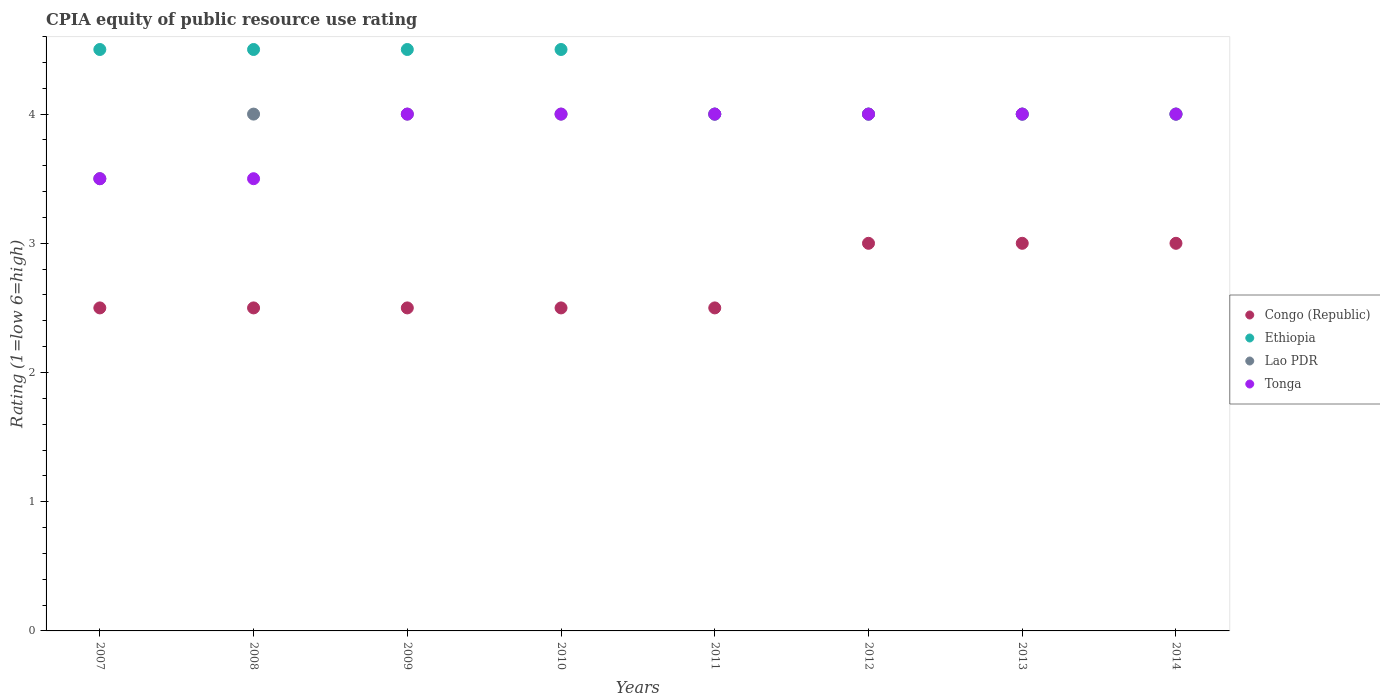Is the number of dotlines equal to the number of legend labels?
Keep it short and to the point. Yes. What is the CPIA rating in Ethiopia in 2007?
Provide a short and direct response. 4.5. Across all years, what is the maximum CPIA rating in Congo (Republic)?
Your answer should be compact. 3. In which year was the CPIA rating in Congo (Republic) maximum?
Your answer should be compact. 2012. What is the difference between the CPIA rating in Ethiopia in 2007 and that in 2013?
Your answer should be very brief. 0.5. What is the difference between the CPIA rating in Congo (Republic) in 2012 and the CPIA rating in Tonga in 2008?
Your response must be concise. -0.5. What is the average CPIA rating in Lao PDR per year?
Your answer should be very brief. 3.94. In the year 2012, what is the difference between the CPIA rating in Tonga and CPIA rating in Congo (Republic)?
Offer a very short reply. 1. What is the ratio of the CPIA rating in Congo (Republic) in 2010 to that in 2013?
Make the answer very short. 0.83. What is the difference between the highest and the second highest CPIA rating in Tonga?
Your response must be concise. 0. Is the sum of the CPIA rating in Lao PDR in 2008 and 2011 greater than the maximum CPIA rating in Congo (Republic) across all years?
Offer a terse response. Yes. Is it the case that in every year, the sum of the CPIA rating in Congo (Republic) and CPIA rating in Lao PDR  is greater than the CPIA rating in Tonga?
Provide a short and direct response. Yes. Does the CPIA rating in Congo (Republic) monotonically increase over the years?
Provide a short and direct response. No. How many years are there in the graph?
Make the answer very short. 8. Does the graph contain any zero values?
Offer a very short reply. No. How many legend labels are there?
Give a very brief answer. 4. What is the title of the graph?
Make the answer very short. CPIA equity of public resource use rating. What is the label or title of the Y-axis?
Offer a terse response. Rating (1=low 6=high). What is the Rating (1=low 6=high) of Ethiopia in 2007?
Offer a very short reply. 4.5. What is the Rating (1=low 6=high) in Lao PDR in 2007?
Your answer should be compact. 3.5. What is the Rating (1=low 6=high) of Congo (Republic) in 2008?
Provide a short and direct response. 2.5. What is the Rating (1=low 6=high) of Lao PDR in 2008?
Make the answer very short. 4. What is the Rating (1=low 6=high) in Tonga in 2008?
Offer a terse response. 3.5. What is the Rating (1=low 6=high) of Congo (Republic) in 2010?
Your answer should be compact. 2.5. What is the Rating (1=low 6=high) of Lao PDR in 2010?
Offer a very short reply. 4. What is the Rating (1=low 6=high) in Congo (Republic) in 2011?
Your answer should be very brief. 2.5. What is the Rating (1=low 6=high) in Ethiopia in 2011?
Offer a terse response. 4. What is the Rating (1=low 6=high) in Tonga in 2011?
Offer a very short reply. 4. What is the Rating (1=low 6=high) in Congo (Republic) in 2012?
Offer a terse response. 3. What is the Rating (1=low 6=high) of Tonga in 2013?
Offer a very short reply. 4. What is the Rating (1=low 6=high) of Ethiopia in 2014?
Give a very brief answer. 4. What is the Rating (1=low 6=high) of Lao PDR in 2014?
Ensure brevity in your answer.  4. Across all years, what is the maximum Rating (1=low 6=high) of Ethiopia?
Your answer should be compact. 4.5. Across all years, what is the maximum Rating (1=low 6=high) of Lao PDR?
Offer a terse response. 4. Across all years, what is the maximum Rating (1=low 6=high) of Tonga?
Ensure brevity in your answer.  4. Across all years, what is the minimum Rating (1=low 6=high) in Lao PDR?
Give a very brief answer. 3.5. Across all years, what is the minimum Rating (1=low 6=high) of Tonga?
Ensure brevity in your answer.  3.5. What is the total Rating (1=low 6=high) of Ethiopia in the graph?
Keep it short and to the point. 34. What is the total Rating (1=low 6=high) in Lao PDR in the graph?
Offer a very short reply. 31.5. What is the total Rating (1=low 6=high) in Tonga in the graph?
Keep it short and to the point. 31. What is the difference between the Rating (1=low 6=high) in Congo (Republic) in 2007 and that in 2008?
Your answer should be compact. 0. What is the difference between the Rating (1=low 6=high) in Tonga in 2007 and that in 2008?
Provide a succinct answer. 0. What is the difference between the Rating (1=low 6=high) in Congo (Republic) in 2007 and that in 2009?
Offer a very short reply. 0. What is the difference between the Rating (1=low 6=high) of Ethiopia in 2007 and that in 2009?
Make the answer very short. 0. What is the difference between the Rating (1=low 6=high) in Lao PDR in 2007 and that in 2009?
Keep it short and to the point. -0.5. What is the difference between the Rating (1=low 6=high) in Tonga in 2007 and that in 2009?
Make the answer very short. -0.5. What is the difference between the Rating (1=low 6=high) of Congo (Republic) in 2007 and that in 2010?
Ensure brevity in your answer.  0. What is the difference between the Rating (1=low 6=high) of Tonga in 2007 and that in 2010?
Ensure brevity in your answer.  -0.5. What is the difference between the Rating (1=low 6=high) in Tonga in 2007 and that in 2011?
Ensure brevity in your answer.  -0.5. What is the difference between the Rating (1=low 6=high) in Congo (Republic) in 2007 and that in 2013?
Make the answer very short. -0.5. What is the difference between the Rating (1=low 6=high) of Lao PDR in 2007 and that in 2013?
Your answer should be compact. -0.5. What is the difference between the Rating (1=low 6=high) in Tonga in 2007 and that in 2013?
Provide a short and direct response. -0.5. What is the difference between the Rating (1=low 6=high) of Congo (Republic) in 2007 and that in 2014?
Ensure brevity in your answer.  -0.5. What is the difference between the Rating (1=low 6=high) of Lao PDR in 2007 and that in 2014?
Your answer should be compact. -0.5. What is the difference between the Rating (1=low 6=high) of Ethiopia in 2008 and that in 2009?
Ensure brevity in your answer.  0. What is the difference between the Rating (1=low 6=high) of Lao PDR in 2008 and that in 2009?
Make the answer very short. 0. What is the difference between the Rating (1=low 6=high) of Congo (Republic) in 2008 and that in 2010?
Keep it short and to the point. 0. What is the difference between the Rating (1=low 6=high) in Ethiopia in 2008 and that in 2010?
Keep it short and to the point. 0. What is the difference between the Rating (1=low 6=high) of Lao PDR in 2008 and that in 2010?
Provide a succinct answer. 0. What is the difference between the Rating (1=low 6=high) of Congo (Republic) in 2008 and that in 2011?
Your answer should be compact. 0. What is the difference between the Rating (1=low 6=high) of Ethiopia in 2008 and that in 2011?
Offer a terse response. 0.5. What is the difference between the Rating (1=low 6=high) of Lao PDR in 2008 and that in 2011?
Give a very brief answer. 0. What is the difference between the Rating (1=low 6=high) of Tonga in 2008 and that in 2011?
Give a very brief answer. -0.5. What is the difference between the Rating (1=low 6=high) of Congo (Republic) in 2008 and that in 2012?
Offer a terse response. -0.5. What is the difference between the Rating (1=low 6=high) in Ethiopia in 2008 and that in 2012?
Your response must be concise. 0.5. What is the difference between the Rating (1=low 6=high) of Ethiopia in 2008 and that in 2013?
Offer a very short reply. 0.5. What is the difference between the Rating (1=low 6=high) of Congo (Republic) in 2008 and that in 2014?
Your answer should be compact. -0.5. What is the difference between the Rating (1=low 6=high) in Tonga in 2008 and that in 2014?
Ensure brevity in your answer.  -0.5. What is the difference between the Rating (1=low 6=high) in Congo (Republic) in 2009 and that in 2010?
Make the answer very short. 0. What is the difference between the Rating (1=low 6=high) in Ethiopia in 2009 and that in 2010?
Provide a short and direct response. 0. What is the difference between the Rating (1=low 6=high) in Lao PDR in 2009 and that in 2010?
Offer a terse response. 0. What is the difference between the Rating (1=low 6=high) in Tonga in 2009 and that in 2010?
Make the answer very short. 0. What is the difference between the Rating (1=low 6=high) of Tonga in 2009 and that in 2012?
Ensure brevity in your answer.  0. What is the difference between the Rating (1=low 6=high) in Congo (Republic) in 2009 and that in 2013?
Provide a succinct answer. -0.5. What is the difference between the Rating (1=low 6=high) of Tonga in 2009 and that in 2013?
Provide a succinct answer. 0. What is the difference between the Rating (1=low 6=high) of Ethiopia in 2009 and that in 2014?
Your answer should be very brief. 0.5. What is the difference between the Rating (1=low 6=high) in Tonga in 2009 and that in 2014?
Keep it short and to the point. 0. What is the difference between the Rating (1=low 6=high) of Lao PDR in 2010 and that in 2011?
Provide a short and direct response. 0. What is the difference between the Rating (1=low 6=high) of Tonga in 2010 and that in 2011?
Ensure brevity in your answer.  0. What is the difference between the Rating (1=low 6=high) of Congo (Republic) in 2010 and that in 2012?
Offer a very short reply. -0.5. What is the difference between the Rating (1=low 6=high) in Ethiopia in 2010 and that in 2012?
Your response must be concise. 0.5. What is the difference between the Rating (1=low 6=high) in Ethiopia in 2010 and that in 2013?
Provide a succinct answer. 0.5. What is the difference between the Rating (1=low 6=high) of Congo (Republic) in 2010 and that in 2014?
Give a very brief answer. -0.5. What is the difference between the Rating (1=low 6=high) in Ethiopia in 2010 and that in 2014?
Make the answer very short. 0.5. What is the difference between the Rating (1=low 6=high) in Lao PDR in 2010 and that in 2014?
Your response must be concise. 0. What is the difference between the Rating (1=low 6=high) of Tonga in 2010 and that in 2014?
Provide a short and direct response. 0. What is the difference between the Rating (1=low 6=high) in Congo (Republic) in 2011 and that in 2012?
Offer a very short reply. -0.5. What is the difference between the Rating (1=low 6=high) of Ethiopia in 2011 and that in 2012?
Provide a succinct answer. 0. What is the difference between the Rating (1=low 6=high) of Tonga in 2011 and that in 2012?
Provide a short and direct response. 0. What is the difference between the Rating (1=low 6=high) in Congo (Republic) in 2011 and that in 2013?
Give a very brief answer. -0.5. What is the difference between the Rating (1=low 6=high) of Ethiopia in 2011 and that in 2013?
Make the answer very short. 0. What is the difference between the Rating (1=low 6=high) of Congo (Republic) in 2011 and that in 2014?
Your answer should be compact. -0.5. What is the difference between the Rating (1=low 6=high) of Lao PDR in 2011 and that in 2014?
Ensure brevity in your answer.  0. What is the difference between the Rating (1=low 6=high) of Congo (Republic) in 2012 and that in 2013?
Make the answer very short. 0. What is the difference between the Rating (1=low 6=high) of Ethiopia in 2012 and that in 2013?
Give a very brief answer. 0. What is the difference between the Rating (1=low 6=high) in Lao PDR in 2012 and that in 2013?
Ensure brevity in your answer.  0. What is the difference between the Rating (1=low 6=high) of Tonga in 2012 and that in 2013?
Your answer should be very brief. 0. What is the difference between the Rating (1=low 6=high) in Ethiopia in 2012 and that in 2014?
Give a very brief answer. 0. What is the difference between the Rating (1=low 6=high) of Lao PDR in 2012 and that in 2014?
Your response must be concise. 0. What is the difference between the Rating (1=low 6=high) in Tonga in 2012 and that in 2014?
Make the answer very short. 0. What is the difference between the Rating (1=low 6=high) of Congo (Republic) in 2013 and that in 2014?
Your answer should be very brief. 0. What is the difference between the Rating (1=low 6=high) in Ethiopia in 2013 and that in 2014?
Ensure brevity in your answer.  0. What is the difference between the Rating (1=low 6=high) in Congo (Republic) in 2007 and the Rating (1=low 6=high) in Ethiopia in 2008?
Your response must be concise. -2. What is the difference between the Rating (1=low 6=high) of Congo (Republic) in 2007 and the Rating (1=low 6=high) of Tonga in 2008?
Your answer should be very brief. -1. What is the difference between the Rating (1=low 6=high) in Congo (Republic) in 2007 and the Rating (1=low 6=high) in Ethiopia in 2009?
Provide a short and direct response. -2. What is the difference between the Rating (1=low 6=high) of Congo (Republic) in 2007 and the Rating (1=low 6=high) of Lao PDR in 2009?
Your response must be concise. -1.5. What is the difference between the Rating (1=low 6=high) of Ethiopia in 2007 and the Rating (1=low 6=high) of Lao PDR in 2009?
Offer a terse response. 0.5. What is the difference between the Rating (1=low 6=high) of Ethiopia in 2007 and the Rating (1=low 6=high) of Tonga in 2009?
Ensure brevity in your answer.  0.5. What is the difference between the Rating (1=low 6=high) in Lao PDR in 2007 and the Rating (1=low 6=high) in Tonga in 2010?
Provide a succinct answer. -0.5. What is the difference between the Rating (1=low 6=high) of Congo (Republic) in 2007 and the Rating (1=low 6=high) of Lao PDR in 2011?
Offer a terse response. -1.5. What is the difference between the Rating (1=low 6=high) in Congo (Republic) in 2007 and the Rating (1=low 6=high) in Tonga in 2011?
Provide a succinct answer. -1.5. What is the difference between the Rating (1=low 6=high) of Ethiopia in 2007 and the Rating (1=low 6=high) of Tonga in 2011?
Ensure brevity in your answer.  0.5. What is the difference between the Rating (1=low 6=high) of Congo (Republic) in 2007 and the Rating (1=low 6=high) of Ethiopia in 2012?
Give a very brief answer. -1.5. What is the difference between the Rating (1=low 6=high) of Congo (Republic) in 2007 and the Rating (1=low 6=high) of Lao PDR in 2012?
Your answer should be very brief. -1.5. What is the difference between the Rating (1=low 6=high) in Congo (Republic) in 2007 and the Rating (1=low 6=high) in Tonga in 2012?
Ensure brevity in your answer.  -1.5. What is the difference between the Rating (1=low 6=high) of Ethiopia in 2007 and the Rating (1=low 6=high) of Tonga in 2012?
Offer a very short reply. 0.5. What is the difference between the Rating (1=low 6=high) of Lao PDR in 2007 and the Rating (1=low 6=high) of Tonga in 2012?
Make the answer very short. -0.5. What is the difference between the Rating (1=low 6=high) of Congo (Republic) in 2007 and the Rating (1=low 6=high) of Lao PDR in 2013?
Give a very brief answer. -1.5. What is the difference between the Rating (1=low 6=high) of Congo (Republic) in 2007 and the Rating (1=low 6=high) of Tonga in 2013?
Offer a very short reply. -1.5. What is the difference between the Rating (1=low 6=high) in Lao PDR in 2007 and the Rating (1=low 6=high) in Tonga in 2013?
Your answer should be compact. -0.5. What is the difference between the Rating (1=low 6=high) of Congo (Republic) in 2007 and the Rating (1=low 6=high) of Lao PDR in 2014?
Your answer should be very brief. -1.5. What is the difference between the Rating (1=low 6=high) of Ethiopia in 2007 and the Rating (1=low 6=high) of Lao PDR in 2014?
Your answer should be compact. 0.5. What is the difference between the Rating (1=low 6=high) in Lao PDR in 2007 and the Rating (1=low 6=high) in Tonga in 2014?
Make the answer very short. -0.5. What is the difference between the Rating (1=low 6=high) of Congo (Republic) in 2008 and the Rating (1=low 6=high) of Ethiopia in 2009?
Offer a very short reply. -2. What is the difference between the Rating (1=low 6=high) in Congo (Republic) in 2008 and the Rating (1=low 6=high) in Tonga in 2009?
Give a very brief answer. -1.5. What is the difference between the Rating (1=low 6=high) of Ethiopia in 2008 and the Rating (1=low 6=high) of Tonga in 2009?
Provide a succinct answer. 0.5. What is the difference between the Rating (1=low 6=high) of Congo (Republic) in 2008 and the Rating (1=low 6=high) of Ethiopia in 2010?
Your answer should be compact. -2. What is the difference between the Rating (1=low 6=high) in Ethiopia in 2008 and the Rating (1=low 6=high) in Lao PDR in 2010?
Provide a succinct answer. 0.5. What is the difference between the Rating (1=low 6=high) in Lao PDR in 2008 and the Rating (1=low 6=high) in Tonga in 2010?
Offer a terse response. 0. What is the difference between the Rating (1=low 6=high) in Congo (Republic) in 2008 and the Rating (1=low 6=high) in Ethiopia in 2011?
Your answer should be very brief. -1.5. What is the difference between the Rating (1=low 6=high) of Ethiopia in 2008 and the Rating (1=low 6=high) of Lao PDR in 2011?
Your answer should be very brief. 0.5. What is the difference between the Rating (1=low 6=high) in Ethiopia in 2008 and the Rating (1=low 6=high) in Tonga in 2011?
Your answer should be compact. 0.5. What is the difference between the Rating (1=low 6=high) in Congo (Republic) in 2008 and the Rating (1=low 6=high) in Lao PDR in 2012?
Make the answer very short. -1.5. What is the difference between the Rating (1=low 6=high) in Ethiopia in 2008 and the Rating (1=low 6=high) in Lao PDR in 2012?
Your response must be concise. 0.5. What is the difference between the Rating (1=low 6=high) of Congo (Republic) in 2008 and the Rating (1=low 6=high) of Ethiopia in 2013?
Offer a terse response. -1.5. What is the difference between the Rating (1=low 6=high) of Congo (Republic) in 2008 and the Rating (1=low 6=high) of Tonga in 2013?
Provide a succinct answer. -1.5. What is the difference between the Rating (1=low 6=high) in Ethiopia in 2008 and the Rating (1=low 6=high) in Lao PDR in 2013?
Ensure brevity in your answer.  0.5. What is the difference between the Rating (1=low 6=high) of Ethiopia in 2008 and the Rating (1=low 6=high) of Tonga in 2013?
Your answer should be compact. 0.5. What is the difference between the Rating (1=low 6=high) of Congo (Republic) in 2008 and the Rating (1=low 6=high) of Ethiopia in 2014?
Offer a very short reply. -1.5. What is the difference between the Rating (1=low 6=high) in Congo (Republic) in 2008 and the Rating (1=low 6=high) in Tonga in 2014?
Your answer should be compact. -1.5. What is the difference between the Rating (1=low 6=high) of Ethiopia in 2008 and the Rating (1=low 6=high) of Lao PDR in 2014?
Your answer should be very brief. 0.5. What is the difference between the Rating (1=low 6=high) in Ethiopia in 2008 and the Rating (1=low 6=high) in Tonga in 2014?
Make the answer very short. 0.5. What is the difference between the Rating (1=low 6=high) in Lao PDR in 2008 and the Rating (1=low 6=high) in Tonga in 2014?
Keep it short and to the point. 0. What is the difference between the Rating (1=low 6=high) of Congo (Republic) in 2009 and the Rating (1=low 6=high) of Ethiopia in 2010?
Your answer should be very brief. -2. What is the difference between the Rating (1=low 6=high) of Congo (Republic) in 2009 and the Rating (1=low 6=high) of Lao PDR in 2010?
Make the answer very short. -1.5. What is the difference between the Rating (1=low 6=high) of Congo (Republic) in 2009 and the Rating (1=low 6=high) of Tonga in 2010?
Provide a short and direct response. -1.5. What is the difference between the Rating (1=low 6=high) in Ethiopia in 2009 and the Rating (1=low 6=high) in Tonga in 2010?
Offer a very short reply. 0.5. What is the difference between the Rating (1=low 6=high) in Lao PDR in 2009 and the Rating (1=low 6=high) in Tonga in 2010?
Provide a short and direct response. 0. What is the difference between the Rating (1=low 6=high) in Congo (Republic) in 2009 and the Rating (1=low 6=high) in Lao PDR in 2011?
Ensure brevity in your answer.  -1.5. What is the difference between the Rating (1=low 6=high) in Ethiopia in 2009 and the Rating (1=low 6=high) in Lao PDR in 2011?
Ensure brevity in your answer.  0.5. What is the difference between the Rating (1=low 6=high) of Ethiopia in 2009 and the Rating (1=low 6=high) of Tonga in 2011?
Make the answer very short. 0.5. What is the difference between the Rating (1=low 6=high) in Lao PDR in 2009 and the Rating (1=low 6=high) in Tonga in 2011?
Offer a terse response. 0. What is the difference between the Rating (1=low 6=high) of Congo (Republic) in 2009 and the Rating (1=low 6=high) of Lao PDR in 2012?
Provide a short and direct response. -1.5. What is the difference between the Rating (1=low 6=high) in Congo (Republic) in 2009 and the Rating (1=low 6=high) in Tonga in 2012?
Provide a short and direct response. -1.5. What is the difference between the Rating (1=low 6=high) of Ethiopia in 2009 and the Rating (1=low 6=high) of Lao PDR in 2012?
Your answer should be very brief. 0.5. What is the difference between the Rating (1=low 6=high) of Ethiopia in 2009 and the Rating (1=low 6=high) of Tonga in 2012?
Offer a terse response. 0.5. What is the difference between the Rating (1=low 6=high) of Congo (Republic) in 2009 and the Rating (1=low 6=high) of Ethiopia in 2013?
Provide a succinct answer. -1.5. What is the difference between the Rating (1=low 6=high) in Congo (Republic) in 2009 and the Rating (1=low 6=high) in Lao PDR in 2013?
Give a very brief answer. -1.5. What is the difference between the Rating (1=low 6=high) in Congo (Republic) in 2009 and the Rating (1=low 6=high) in Tonga in 2013?
Keep it short and to the point. -1.5. What is the difference between the Rating (1=low 6=high) in Ethiopia in 2009 and the Rating (1=low 6=high) in Tonga in 2014?
Make the answer very short. 0.5. What is the difference between the Rating (1=low 6=high) of Congo (Republic) in 2010 and the Rating (1=low 6=high) of Ethiopia in 2011?
Your response must be concise. -1.5. What is the difference between the Rating (1=low 6=high) of Congo (Republic) in 2010 and the Rating (1=low 6=high) of Tonga in 2011?
Ensure brevity in your answer.  -1.5. What is the difference between the Rating (1=low 6=high) of Lao PDR in 2010 and the Rating (1=low 6=high) of Tonga in 2011?
Your answer should be very brief. 0. What is the difference between the Rating (1=low 6=high) in Congo (Republic) in 2010 and the Rating (1=low 6=high) in Ethiopia in 2012?
Offer a terse response. -1.5. What is the difference between the Rating (1=low 6=high) of Congo (Republic) in 2010 and the Rating (1=low 6=high) of Lao PDR in 2012?
Ensure brevity in your answer.  -1.5. What is the difference between the Rating (1=low 6=high) in Congo (Republic) in 2010 and the Rating (1=low 6=high) in Tonga in 2012?
Offer a terse response. -1.5. What is the difference between the Rating (1=low 6=high) in Ethiopia in 2010 and the Rating (1=low 6=high) in Lao PDR in 2012?
Your response must be concise. 0.5. What is the difference between the Rating (1=low 6=high) of Lao PDR in 2010 and the Rating (1=low 6=high) of Tonga in 2012?
Make the answer very short. 0. What is the difference between the Rating (1=low 6=high) of Ethiopia in 2010 and the Rating (1=low 6=high) of Tonga in 2013?
Give a very brief answer. 0.5. What is the difference between the Rating (1=low 6=high) of Lao PDR in 2010 and the Rating (1=low 6=high) of Tonga in 2013?
Provide a succinct answer. 0. What is the difference between the Rating (1=low 6=high) of Congo (Republic) in 2010 and the Rating (1=low 6=high) of Ethiopia in 2014?
Keep it short and to the point. -1.5. What is the difference between the Rating (1=low 6=high) in Congo (Republic) in 2010 and the Rating (1=low 6=high) in Tonga in 2014?
Your answer should be very brief. -1.5. What is the difference between the Rating (1=low 6=high) of Congo (Republic) in 2011 and the Rating (1=low 6=high) of Lao PDR in 2012?
Provide a short and direct response. -1.5. What is the difference between the Rating (1=low 6=high) of Ethiopia in 2011 and the Rating (1=low 6=high) of Lao PDR in 2013?
Offer a terse response. 0. What is the difference between the Rating (1=low 6=high) in Ethiopia in 2011 and the Rating (1=low 6=high) in Tonga in 2013?
Provide a short and direct response. 0. What is the difference between the Rating (1=low 6=high) of Congo (Republic) in 2011 and the Rating (1=low 6=high) of Ethiopia in 2014?
Provide a short and direct response. -1.5. What is the difference between the Rating (1=low 6=high) of Congo (Republic) in 2011 and the Rating (1=low 6=high) of Lao PDR in 2014?
Your answer should be compact. -1.5. What is the difference between the Rating (1=low 6=high) in Congo (Republic) in 2011 and the Rating (1=low 6=high) in Tonga in 2014?
Offer a very short reply. -1.5. What is the difference between the Rating (1=low 6=high) of Congo (Republic) in 2012 and the Rating (1=low 6=high) of Ethiopia in 2013?
Ensure brevity in your answer.  -1. What is the difference between the Rating (1=low 6=high) in Congo (Republic) in 2012 and the Rating (1=low 6=high) in Lao PDR in 2013?
Keep it short and to the point. -1. What is the difference between the Rating (1=low 6=high) of Ethiopia in 2012 and the Rating (1=low 6=high) of Tonga in 2013?
Offer a very short reply. 0. What is the difference between the Rating (1=low 6=high) in Ethiopia in 2012 and the Rating (1=low 6=high) in Lao PDR in 2014?
Offer a very short reply. 0. What is the difference between the Rating (1=low 6=high) in Ethiopia in 2012 and the Rating (1=low 6=high) in Tonga in 2014?
Make the answer very short. 0. What is the difference between the Rating (1=low 6=high) in Lao PDR in 2012 and the Rating (1=low 6=high) in Tonga in 2014?
Provide a short and direct response. 0. What is the difference between the Rating (1=low 6=high) of Congo (Republic) in 2013 and the Rating (1=low 6=high) of Ethiopia in 2014?
Offer a terse response. -1. What is the difference between the Rating (1=low 6=high) of Congo (Republic) in 2013 and the Rating (1=low 6=high) of Lao PDR in 2014?
Keep it short and to the point. -1. What is the difference between the Rating (1=low 6=high) of Congo (Republic) in 2013 and the Rating (1=low 6=high) of Tonga in 2014?
Ensure brevity in your answer.  -1. What is the difference between the Rating (1=low 6=high) of Ethiopia in 2013 and the Rating (1=low 6=high) of Lao PDR in 2014?
Ensure brevity in your answer.  0. What is the difference between the Rating (1=low 6=high) of Lao PDR in 2013 and the Rating (1=low 6=high) of Tonga in 2014?
Your answer should be compact. 0. What is the average Rating (1=low 6=high) of Congo (Republic) per year?
Offer a very short reply. 2.69. What is the average Rating (1=low 6=high) of Ethiopia per year?
Offer a very short reply. 4.25. What is the average Rating (1=low 6=high) in Lao PDR per year?
Keep it short and to the point. 3.94. What is the average Rating (1=low 6=high) in Tonga per year?
Provide a succinct answer. 3.88. In the year 2007, what is the difference between the Rating (1=low 6=high) in Congo (Republic) and Rating (1=low 6=high) in Ethiopia?
Your answer should be compact. -2. In the year 2007, what is the difference between the Rating (1=low 6=high) in Ethiopia and Rating (1=low 6=high) in Tonga?
Provide a short and direct response. 1. In the year 2007, what is the difference between the Rating (1=low 6=high) of Lao PDR and Rating (1=low 6=high) of Tonga?
Your answer should be compact. 0. In the year 2008, what is the difference between the Rating (1=low 6=high) in Congo (Republic) and Rating (1=low 6=high) in Ethiopia?
Provide a succinct answer. -2. In the year 2008, what is the difference between the Rating (1=low 6=high) in Congo (Republic) and Rating (1=low 6=high) in Lao PDR?
Offer a very short reply. -1.5. In the year 2008, what is the difference between the Rating (1=low 6=high) in Congo (Republic) and Rating (1=low 6=high) in Tonga?
Ensure brevity in your answer.  -1. In the year 2008, what is the difference between the Rating (1=low 6=high) in Ethiopia and Rating (1=low 6=high) in Lao PDR?
Keep it short and to the point. 0.5. In the year 2008, what is the difference between the Rating (1=low 6=high) in Ethiopia and Rating (1=low 6=high) in Tonga?
Offer a terse response. 1. In the year 2009, what is the difference between the Rating (1=low 6=high) in Congo (Republic) and Rating (1=low 6=high) in Ethiopia?
Your response must be concise. -2. In the year 2009, what is the difference between the Rating (1=low 6=high) of Lao PDR and Rating (1=low 6=high) of Tonga?
Provide a succinct answer. 0. In the year 2010, what is the difference between the Rating (1=low 6=high) in Congo (Republic) and Rating (1=low 6=high) in Ethiopia?
Ensure brevity in your answer.  -2. In the year 2010, what is the difference between the Rating (1=low 6=high) in Congo (Republic) and Rating (1=low 6=high) in Tonga?
Provide a succinct answer. -1.5. In the year 2010, what is the difference between the Rating (1=low 6=high) of Ethiopia and Rating (1=low 6=high) of Tonga?
Make the answer very short. 0.5. In the year 2010, what is the difference between the Rating (1=low 6=high) of Lao PDR and Rating (1=low 6=high) of Tonga?
Provide a short and direct response. 0. In the year 2011, what is the difference between the Rating (1=low 6=high) in Congo (Republic) and Rating (1=low 6=high) in Lao PDR?
Your answer should be very brief. -1.5. In the year 2011, what is the difference between the Rating (1=low 6=high) in Ethiopia and Rating (1=low 6=high) in Lao PDR?
Your response must be concise. 0. In the year 2011, what is the difference between the Rating (1=low 6=high) of Ethiopia and Rating (1=low 6=high) of Tonga?
Your answer should be compact. 0. In the year 2011, what is the difference between the Rating (1=low 6=high) in Lao PDR and Rating (1=low 6=high) in Tonga?
Offer a terse response. 0. In the year 2012, what is the difference between the Rating (1=low 6=high) in Ethiopia and Rating (1=low 6=high) in Lao PDR?
Give a very brief answer. 0. In the year 2012, what is the difference between the Rating (1=low 6=high) of Ethiopia and Rating (1=low 6=high) of Tonga?
Your answer should be compact. 0. In the year 2013, what is the difference between the Rating (1=low 6=high) of Ethiopia and Rating (1=low 6=high) of Lao PDR?
Ensure brevity in your answer.  0. In the year 2013, what is the difference between the Rating (1=low 6=high) of Ethiopia and Rating (1=low 6=high) of Tonga?
Ensure brevity in your answer.  0. In the year 2014, what is the difference between the Rating (1=low 6=high) in Congo (Republic) and Rating (1=low 6=high) in Lao PDR?
Provide a succinct answer. -1. In the year 2014, what is the difference between the Rating (1=low 6=high) in Congo (Republic) and Rating (1=low 6=high) in Tonga?
Your answer should be very brief. -1. In the year 2014, what is the difference between the Rating (1=low 6=high) in Ethiopia and Rating (1=low 6=high) in Lao PDR?
Ensure brevity in your answer.  0. In the year 2014, what is the difference between the Rating (1=low 6=high) in Ethiopia and Rating (1=low 6=high) in Tonga?
Offer a terse response. 0. What is the ratio of the Rating (1=low 6=high) in Ethiopia in 2007 to that in 2008?
Provide a succinct answer. 1. What is the ratio of the Rating (1=low 6=high) of Lao PDR in 2007 to that in 2008?
Make the answer very short. 0.88. What is the ratio of the Rating (1=low 6=high) in Lao PDR in 2007 to that in 2009?
Make the answer very short. 0.88. What is the ratio of the Rating (1=low 6=high) in Congo (Republic) in 2007 to that in 2010?
Provide a succinct answer. 1. What is the ratio of the Rating (1=low 6=high) of Lao PDR in 2007 to that in 2010?
Make the answer very short. 0.88. What is the ratio of the Rating (1=low 6=high) in Tonga in 2007 to that in 2010?
Give a very brief answer. 0.88. What is the ratio of the Rating (1=low 6=high) in Congo (Republic) in 2007 to that in 2011?
Your answer should be very brief. 1. What is the ratio of the Rating (1=low 6=high) of Ethiopia in 2007 to that in 2011?
Your answer should be compact. 1.12. What is the ratio of the Rating (1=low 6=high) in Tonga in 2007 to that in 2011?
Ensure brevity in your answer.  0.88. What is the ratio of the Rating (1=low 6=high) in Ethiopia in 2007 to that in 2012?
Your response must be concise. 1.12. What is the ratio of the Rating (1=low 6=high) in Lao PDR in 2007 to that in 2012?
Ensure brevity in your answer.  0.88. What is the ratio of the Rating (1=low 6=high) in Lao PDR in 2007 to that in 2013?
Ensure brevity in your answer.  0.88. What is the ratio of the Rating (1=low 6=high) in Congo (Republic) in 2007 to that in 2014?
Your answer should be compact. 0.83. What is the ratio of the Rating (1=low 6=high) in Tonga in 2007 to that in 2014?
Offer a terse response. 0.88. What is the ratio of the Rating (1=low 6=high) in Congo (Republic) in 2008 to that in 2009?
Provide a succinct answer. 1. What is the ratio of the Rating (1=low 6=high) of Ethiopia in 2008 to that in 2009?
Your answer should be very brief. 1. What is the ratio of the Rating (1=low 6=high) of Lao PDR in 2008 to that in 2009?
Give a very brief answer. 1. What is the ratio of the Rating (1=low 6=high) of Tonga in 2008 to that in 2009?
Make the answer very short. 0.88. What is the ratio of the Rating (1=low 6=high) in Lao PDR in 2008 to that in 2010?
Offer a very short reply. 1. What is the ratio of the Rating (1=low 6=high) of Congo (Republic) in 2008 to that in 2011?
Offer a terse response. 1. What is the ratio of the Rating (1=low 6=high) in Ethiopia in 2008 to that in 2011?
Give a very brief answer. 1.12. What is the ratio of the Rating (1=low 6=high) in Ethiopia in 2008 to that in 2012?
Ensure brevity in your answer.  1.12. What is the ratio of the Rating (1=low 6=high) in Lao PDR in 2008 to that in 2012?
Keep it short and to the point. 1. What is the ratio of the Rating (1=low 6=high) of Lao PDR in 2008 to that in 2013?
Give a very brief answer. 1. What is the ratio of the Rating (1=low 6=high) of Tonga in 2008 to that in 2013?
Your answer should be very brief. 0.88. What is the ratio of the Rating (1=low 6=high) in Congo (Republic) in 2008 to that in 2014?
Offer a terse response. 0.83. What is the ratio of the Rating (1=low 6=high) of Congo (Republic) in 2009 to that in 2010?
Offer a terse response. 1. What is the ratio of the Rating (1=low 6=high) of Lao PDR in 2009 to that in 2010?
Give a very brief answer. 1. What is the ratio of the Rating (1=low 6=high) of Tonga in 2009 to that in 2010?
Give a very brief answer. 1. What is the ratio of the Rating (1=low 6=high) in Congo (Republic) in 2009 to that in 2011?
Offer a very short reply. 1. What is the ratio of the Rating (1=low 6=high) in Lao PDR in 2009 to that in 2011?
Offer a very short reply. 1. What is the ratio of the Rating (1=low 6=high) of Tonga in 2009 to that in 2011?
Make the answer very short. 1. What is the ratio of the Rating (1=low 6=high) of Ethiopia in 2009 to that in 2012?
Provide a short and direct response. 1.12. What is the ratio of the Rating (1=low 6=high) of Lao PDR in 2009 to that in 2012?
Provide a succinct answer. 1. What is the ratio of the Rating (1=low 6=high) of Congo (Republic) in 2009 to that in 2013?
Your answer should be compact. 0.83. What is the ratio of the Rating (1=low 6=high) of Ethiopia in 2009 to that in 2013?
Give a very brief answer. 1.12. What is the ratio of the Rating (1=low 6=high) in Congo (Republic) in 2009 to that in 2014?
Provide a succinct answer. 0.83. What is the ratio of the Rating (1=low 6=high) of Tonga in 2009 to that in 2014?
Provide a short and direct response. 1. What is the ratio of the Rating (1=low 6=high) of Congo (Republic) in 2010 to that in 2011?
Your answer should be compact. 1. What is the ratio of the Rating (1=low 6=high) in Ethiopia in 2010 to that in 2011?
Offer a very short reply. 1.12. What is the ratio of the Rating (1=low 6=high) of Tonga in 2010 to that in 2011?
Keep it short and to the point. 1. What is the ratio of the Rating (1=low 6=high) of Congo (Republic) in 2010 to that in 2012?
Offer a terse response. 0.83. What is the ratio of the Rating (1=low 6=high) in Tonga in 2010 to that in 2012?
Your response must be concise. 1. What is the ratio of the Rating (1=low 6=high) in Ethiopia in 2010 to that in 2013?
Provide a short and direct response. 1.12. What is the ratio of the Rating (1=low 6=high) of Ethiopia in 2010 to that in 2014?
Keep it short and to the point. 1.12. What is the ratio of the Rating (1=low 6=high) in Lao PDR in 2010 to that in 2014?
Give a very brief answer. 1. What is the ratio of the Rating (1=low 6=high) in Tonga in 2010 to that in 2014?
Offer a terse response. 1. What is the ratio of the Rating (1=low 6=high) in Ethiopia in 2011 to that in 2012?
Keep it short and to the point. 1. What is the ratio of the Rating (1=low 6=high) in Tonga in 2011 to that in 2012?
Give a very brief answer. 1. What is the ratio of the Rating (1=low 6=high) of Ethiopia in 2011 to that in 2013?
Provide a succinct answer. 1. What is the ratio of the Rating (1=low 6=high) in Lao PDR in 2011 to that in 2013?
Ensure brevity in your answer.  1. What is the ratio of the Rating (1=low 6=high) of Ethiopia in 2011 to that in 2014?
Offer a very short reply. 1. What is the ratio of the Rating (1=low 6=high) of Lao PDR in 2011 to that in 2014?
Offer a very short reply. 1. What is the ratio of the Rating (1=low 6=high) in Congo (Republic) in 2012 to that in 2013?
Provide a short and direct response. 1. What is the ratio of the Rating (1=low 6=high) in Lao PDR in 2012 to that in 2013?
Provide a succinct answer. 1. What is the ratio of the Rating (1=low 6=high) in Congo (Republic) in 2012 to that in 2014?
Give a very brief answer. 1. What is the ratio of the Rating (1=low 6=high) of Ethiopia in 2012 to that in 2014?
Make the answer very short. 1. What is the ratio of the Rating (1=low 6=high) of Lao PDR in 2012 to that in 2014?
Offer a very short reply. 1. What is the ratio of the Rating (1=low 6=high) in Congo (Republic) in 2013 to that in 2014?
Provide a short and direct response. 1. What is the ratio of the Rating (1=low 6=high) in Ethiopia in 2013 to that in 2014?
Your answer should be very brief. 1. What is the ratio of the Rating (1=low 6=high) in Lao PDR in 2013 to that in 2014?
Keep it short and to the point. 1. What is the ratio of the Rating (1=low 6=high) of Tonga in 2013 to that in 2014?
Make the answer very short. 1. What is the difference between the highest and the second highest Rating (1=low 6=high) in Congo (Republic)?
Offer a very short reply. 0. What is the difference between the highest and the lowest Rating (1=low 6=high) in Congo (Republic)?
Provide a short and direct response. 0.5. What is the difference between the highest and the lowest Rating (1=low 6=high) in Lao PDR?
Provide a succinct answer. 0.5. 